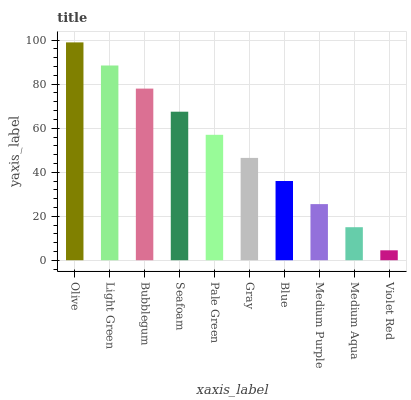Is Violet Red the minimum?
Answer yes or no. Yes. Is Olive the maximum?
Answer yes or no. Yes. Is Light Green the minimum?
Answer yes or no. No. Is Light Green the maximum?
Answer yes or no. No. Is Olive greater than Light Green?
Answer yes or no. Yes. Is Light Green less than Olive?
Answer yes or no. Yes. Is Light Green greater than Olive?
Answer yes or no. No. Is Olive less than Light Green?
Answer yes or no. No. Is Pale Green the high median?
Answer yes or no. Yes. Is Gray the low median?
Answer yes or no. Yes. Is Medium Aqua the high median?
Answer yes or no. No. Is Bubblegum the low median?
Answer yes or no. No. 